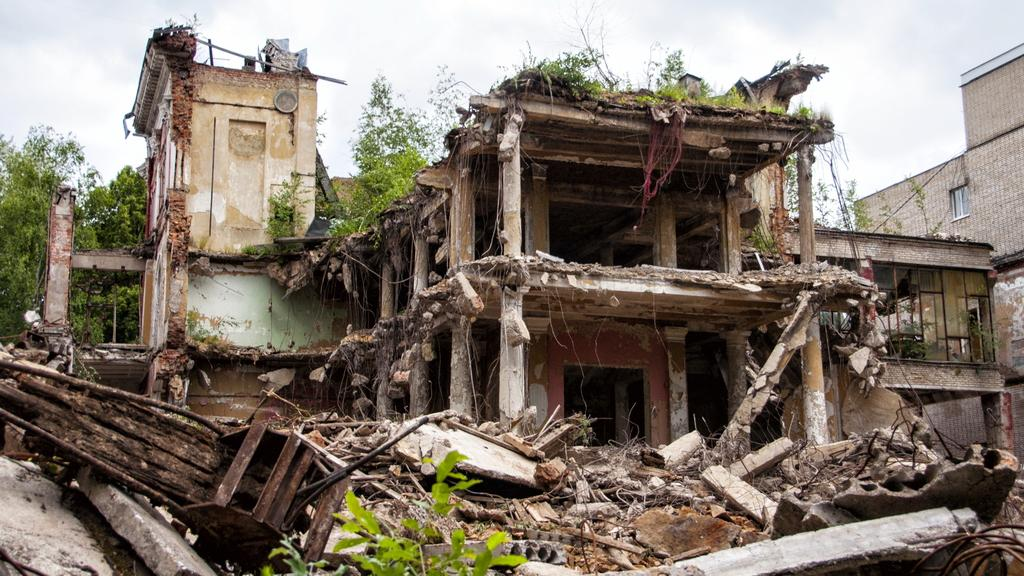What type of structures can be seen in the image? There are collapsed buildings in the image. What can be seen in the background of the image? There are trees and the sky visible in the background of the image. What architectural elements are present in the image? There are pillars and iron rods in the image. What type of jeans can be seen hanging on the trees in the image? There are no jeans present in the image; it features collapsed buildings, trees, the sky, pillars, and iron rods. 